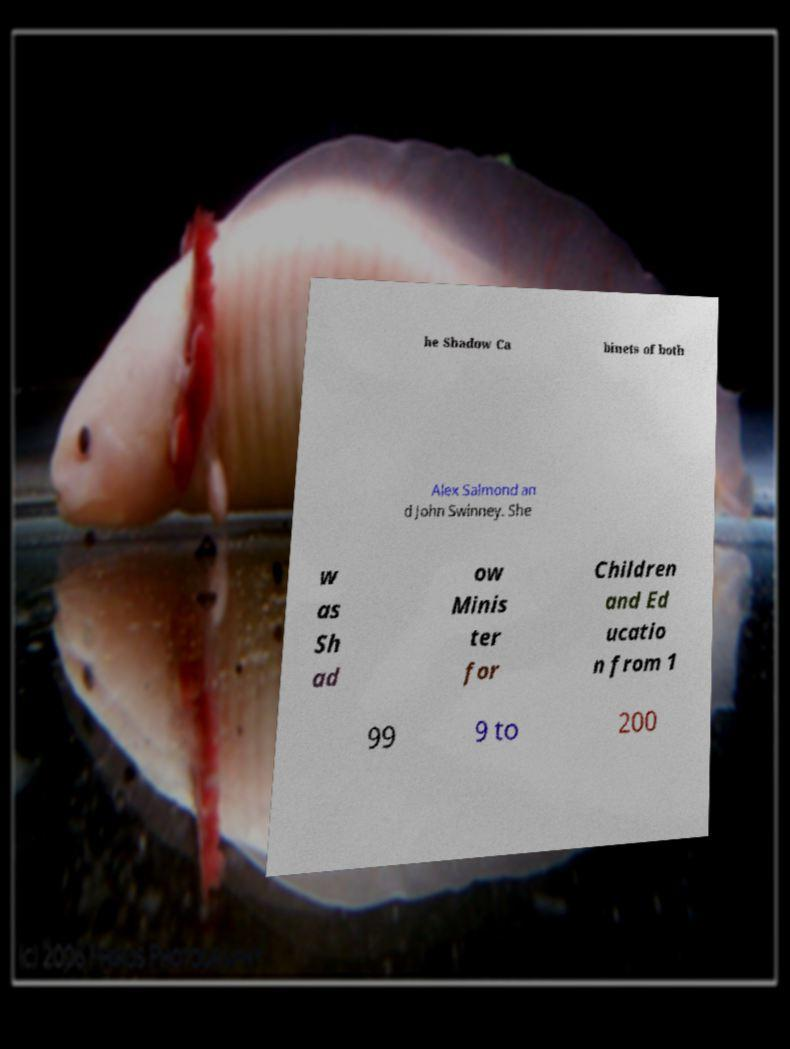For documentation purposes, I need the text within this image transcribed. Could you provide that? he Shadow Ca binets of both Alex Salmond an d John Swinney. She w as Sh ad ow Minis ter for Children and Ed ucatio n from 1 99 9 to 200 